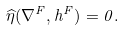<formula> <loc_0><loc_0><loc_500><loc_500>\widehat { \eta } ( \nabla ^ { F } , h ^ { F } ) = 0 .</formula> 